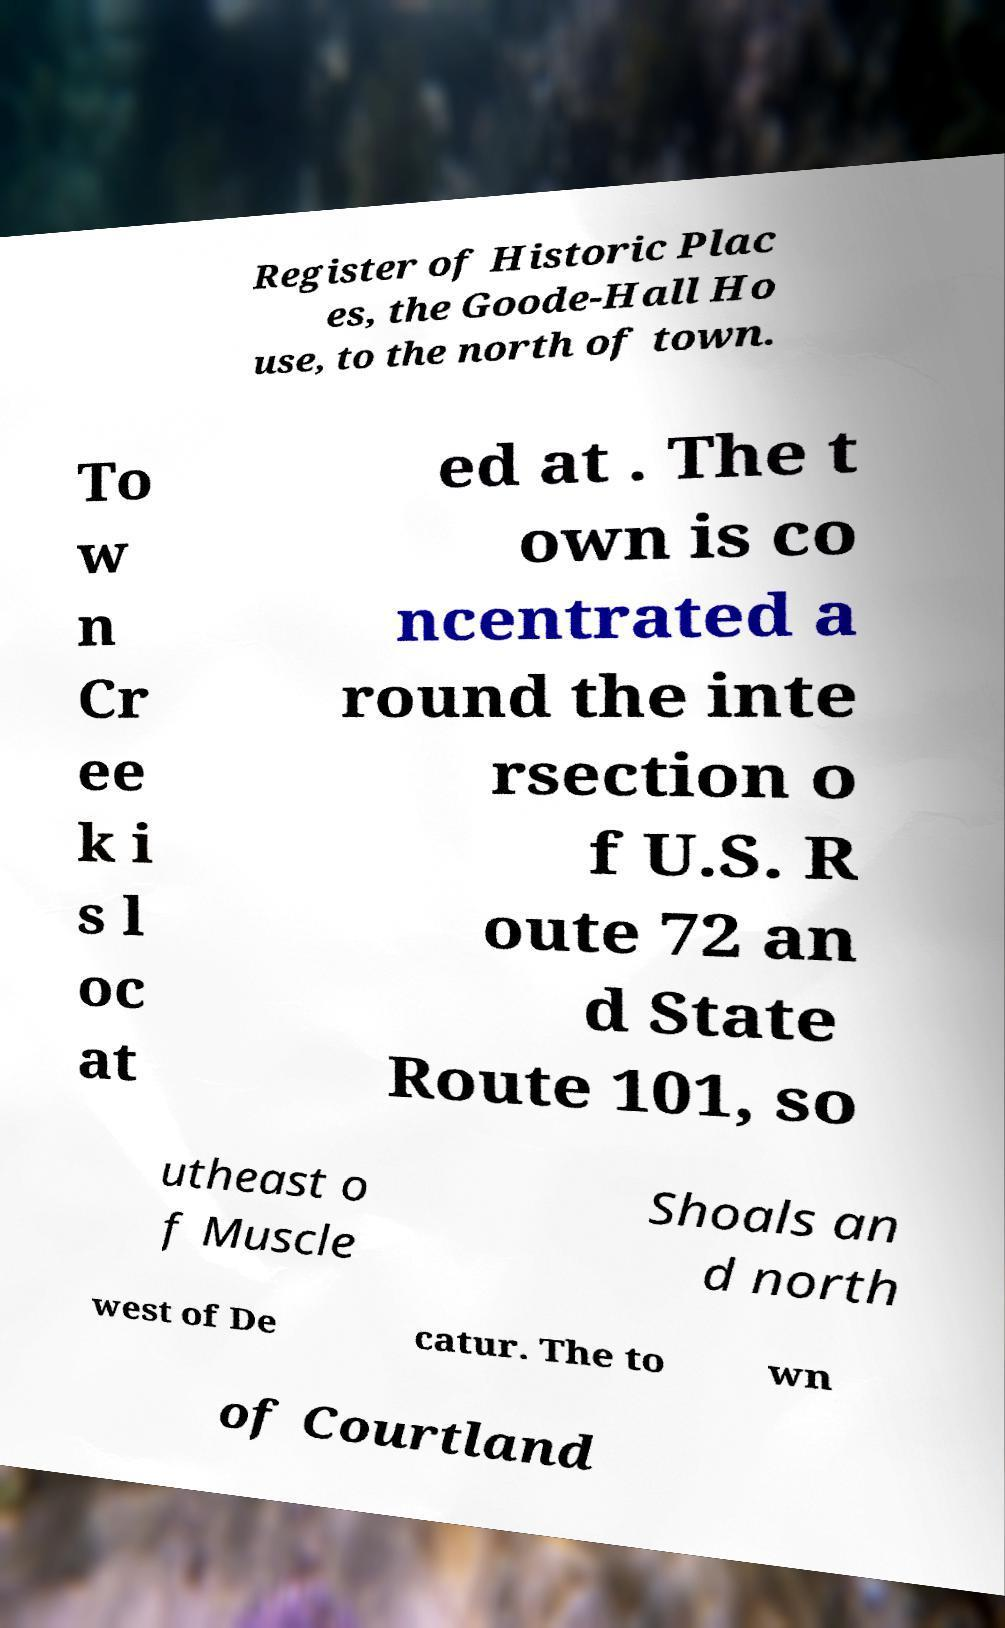Can you accurately transcribe the text from the provided image for me? Register of Historic Plac es, the Goode-Hall Ho use, to the north of town. To w n Cr ee k i s l oc at ed at . The t own is co ncentrated a round the inte rsection o f U.S. R oute 72 an d State Route 101, so utheast o f Muscle Shoals an d north west of De catur. The to wn of Courtland 